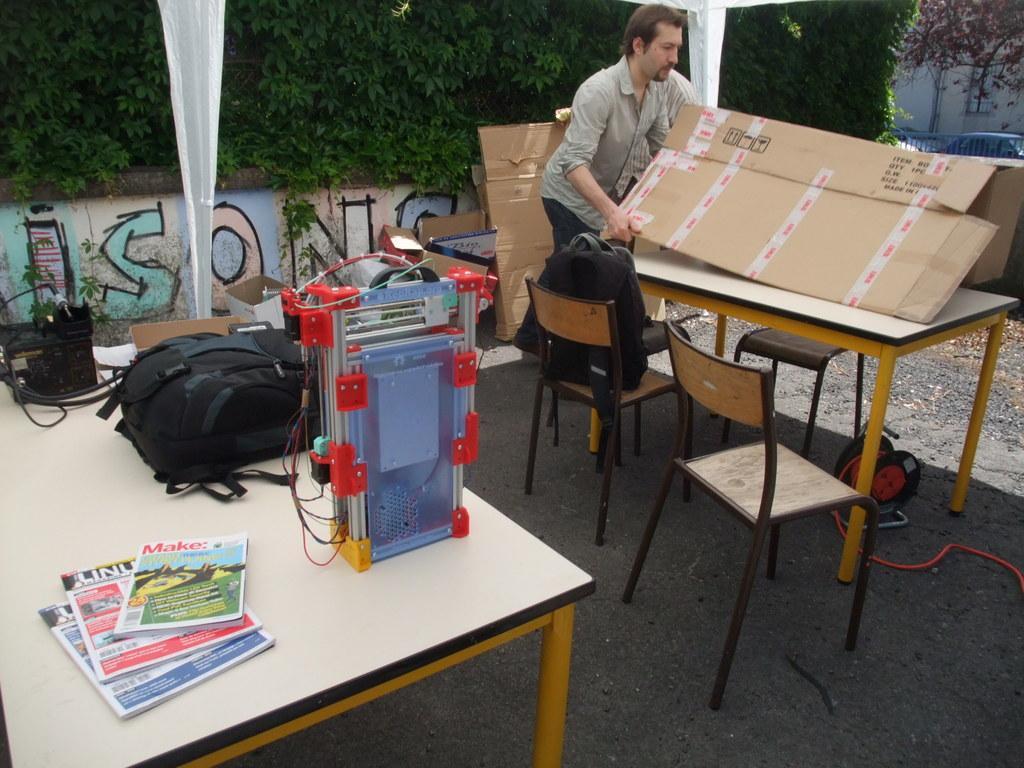How would you summarize this image in a sentence or two? in this image there is a man holding the cardboard on the table there are three chair, there is a bag on the table. There are some books,machine and a bag on the table. The background there is a wall,tree and a curtain. Beside the cart board there is a railing and a car. 